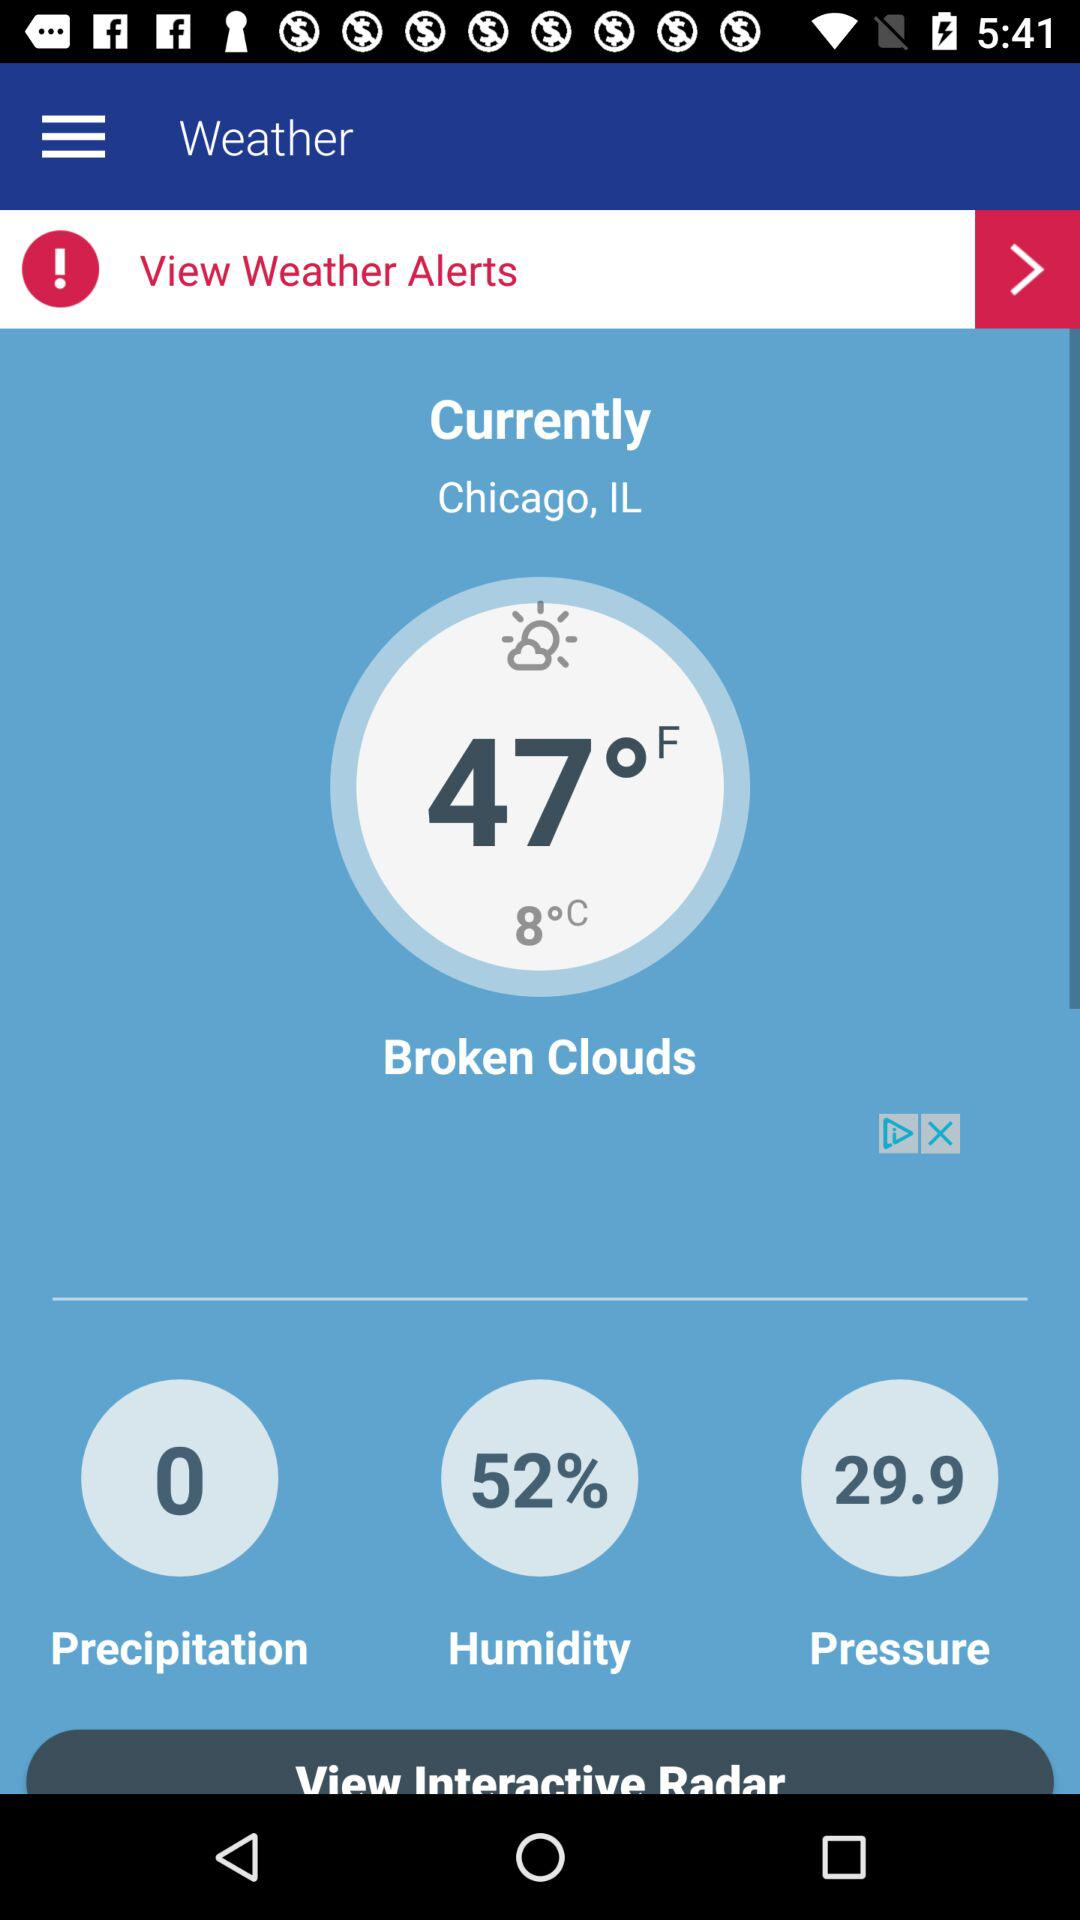What is the percentage of humidity? The humidity is 52%. 